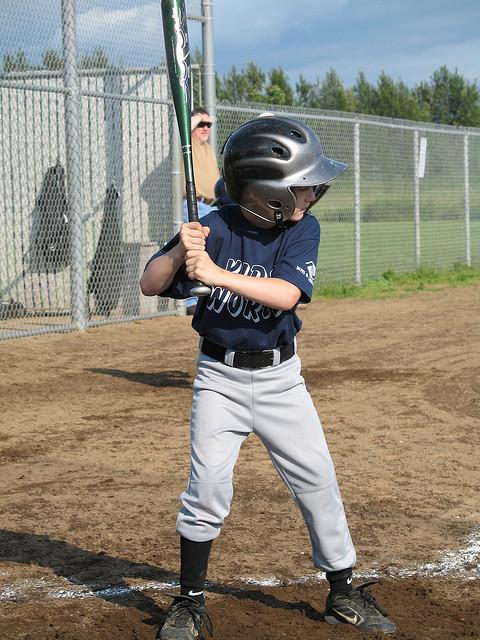What is the boy holding?
Be succinct. Bat. What is the man in the background wearing on his face?
Answer briefly. Sunglasses. What color is the bin in the background?
Write a very short answer. Gray. Is this a professional baseball player?
Short answer required. No. 